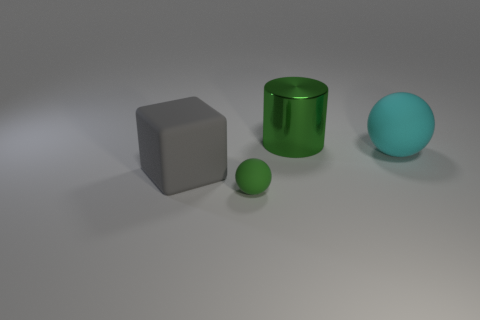Is the shape of the green object in front of the cyan object the same as  the large cyan thing?
Keep it short and to the point. Yes. There is a big rubber object that is to the left of the green thing behind the big gray matte object; what shape is it?
Make the answer very short. Cube. What size is the green object that is left of the green object that is behind the big matte thing that is in front of the big cyan matte thing?
Offer a terse response. Small. There is another thing that is the same shape as the small rubber thing; what is its color?
Your answer should be very brief. Cyan. Does the shiny thing have the same size as the cyan rubber sphere?
Your answer should be compact. Yes. There is a thing that is left of the green rubber ball; what is its material?
Your answer should be compact. Rubber. What number of other things are there of the same shape as the large gray object?
Your answer should be very brief. 0. Is the shape of the large green thing the same as the big cyan matte thing?
Keep it short and to the point. No. There is a tiny rubber sphere; are there any big spheres right of it?
Offer a terse response. Yes. What number of things are either blocks or large matte spheres?
Offer a terse response. 2. 